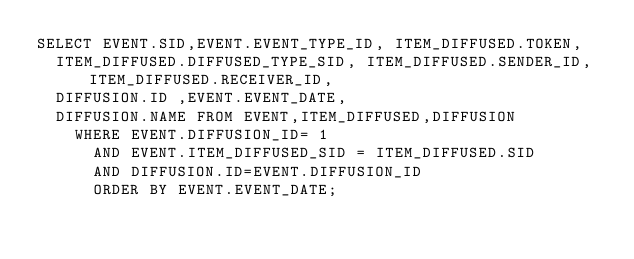Convert code to text. <code><loc_0><loc_0><loc_500><loc_500><_SQL_>SELECT EVENT.SID,EVENT.EVENT_TYPE_ID, ITEM_DIFFUSED.TOKEN, 
	ITEM_DIFFUSED.DIFFUSED_TYPE_SID, ITEM_DIFFUSED.SENDER_ID, ITEM_DIFFUSED.RECEIVER_ID, 
	DIFFUSION.ID ,EVENT.EVENT_DATE, 
	DIFFUSION.NAME FROM EVENT,ITEM_DIFFUSED,DIFFUSION 
		WHERE EVENT.DIFFUSION_ID= 1
			AND EVENT.ITEM_DIFFUSED_SID = ITEM_DIFFUSED.SID
			AND DIFFUSION.ID=EVENT.DIFFUSION_ID 
			ORDER BY EVENT.EVENT_DATE;
</code> 